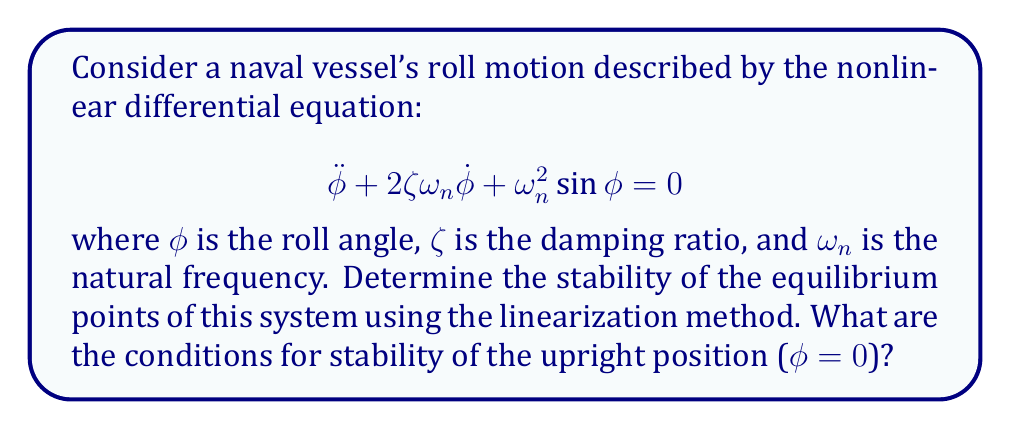Show me your answer to this math problem. 1. Identify the equilibrium points:
   Set $\dot{\phi} = 0$ and $\ddot{\phi} = 0$ in the original equation:
   $$\omega_n^2\sin{\phi} = 0$$
   This gives us two equilibrium points: $\phi = 0$ and $\phi = \pi$.

2. Linearize the system around $\phi = 0$:
   Let $x_1 = \phi$ and $x_2 = \dot{\phi}$. The system can be rewritten as:
   $$\dot{x_1} = x_2$$
   $$\dot{x_2} = -2\zeta\omega_n x_2 - \omega_n^2\sin{x_1}$$

3. Calculate the Jacobian matrix at $\phi = 0$:
   $$J = \begin{bmatrix}
   \frac{\partial \dot{x_1}}{\partial x_1} & \frac{\partial \dot{x_1}}{\partial x_2} \\
   \frac{\partial \dot{x_2}}{\partial x_1} & \frac{\partial \dot{x_2}}{\partial x_2}
   \end{bmatrix} = \begin{bmatrix}
   0 & 1 \\
   -\omega_n^2\cos{x_1} & -2\zeta\omega_n
   \end{bmatrix}$$

   At $\phi = 0$: 
   $$J(0) = \begin{bmatrix}
   0 & 1 \\
   -\omega_n^2 & -2\zeta\omega_n
   \end{bmatrix}$$

4. Find the eigenvalues of $J(0)$:
   $$\det(J(0) - \lambda I) = \lambda^2 + 2\zeta\omega_n\lambda + \omega_n^2 = 0$$
   The characteristic equation is:
   $$\lambda^2 + 2\zeta\omega_n\lambda + \omega_n^2 = 0$$

5. Analyze the eigenvalues:
   For stability, we need the real parts of both eigenvalues to be negative.
   This occurs when $\zeta > 0$ and $\omega_n > 0$.

Therefore, the upright position ($\phi = 0$) is stable when $\zeta > 0$ and $\omega_n > 0$.
Answer: $\zeta > 0$ and $\omega_n > 0$ 